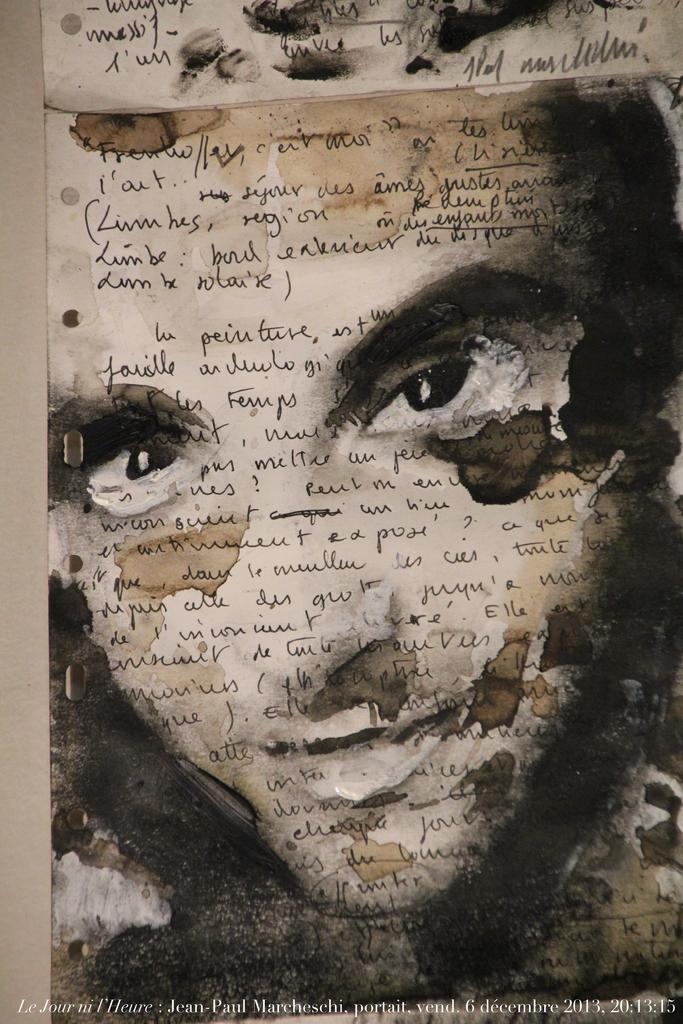What is depicted on the paper in the image? There is a face of a human on the paper. What else can be seen on the paper besides the human face? There is text on the paper. Can you describe any additional features of the paper? There is a watermark in the picture. What is the color of the background in the image? The background is white. What type of creature is shown interacting with the authority in the image? There is no creature or authority present in the image; it only features a face on a paper with text and a watermark. What is the name of the winner of the competition depicted in the image? There is no competition or winner present in the image. 